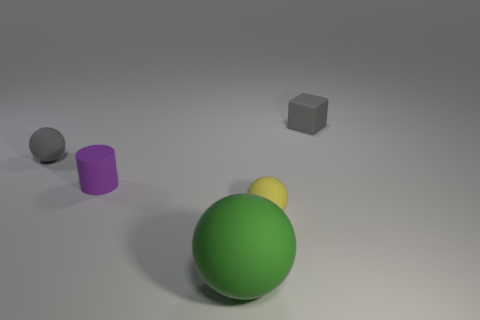Add 2 tiny metal cylinders. How many objects exist? 7 Subtract all cylinders. How many objects are left? 4 Add 5 purple matte things. How many purple matte things are left? 6 Add 1 large green rubber things. How many large green rubber things exist? 2 Subtract 1 green spheres. How many objects are left? 4 Subtract all small brown rubber cylinders. Subtract all purple rubber things. How many objects are left? 4 